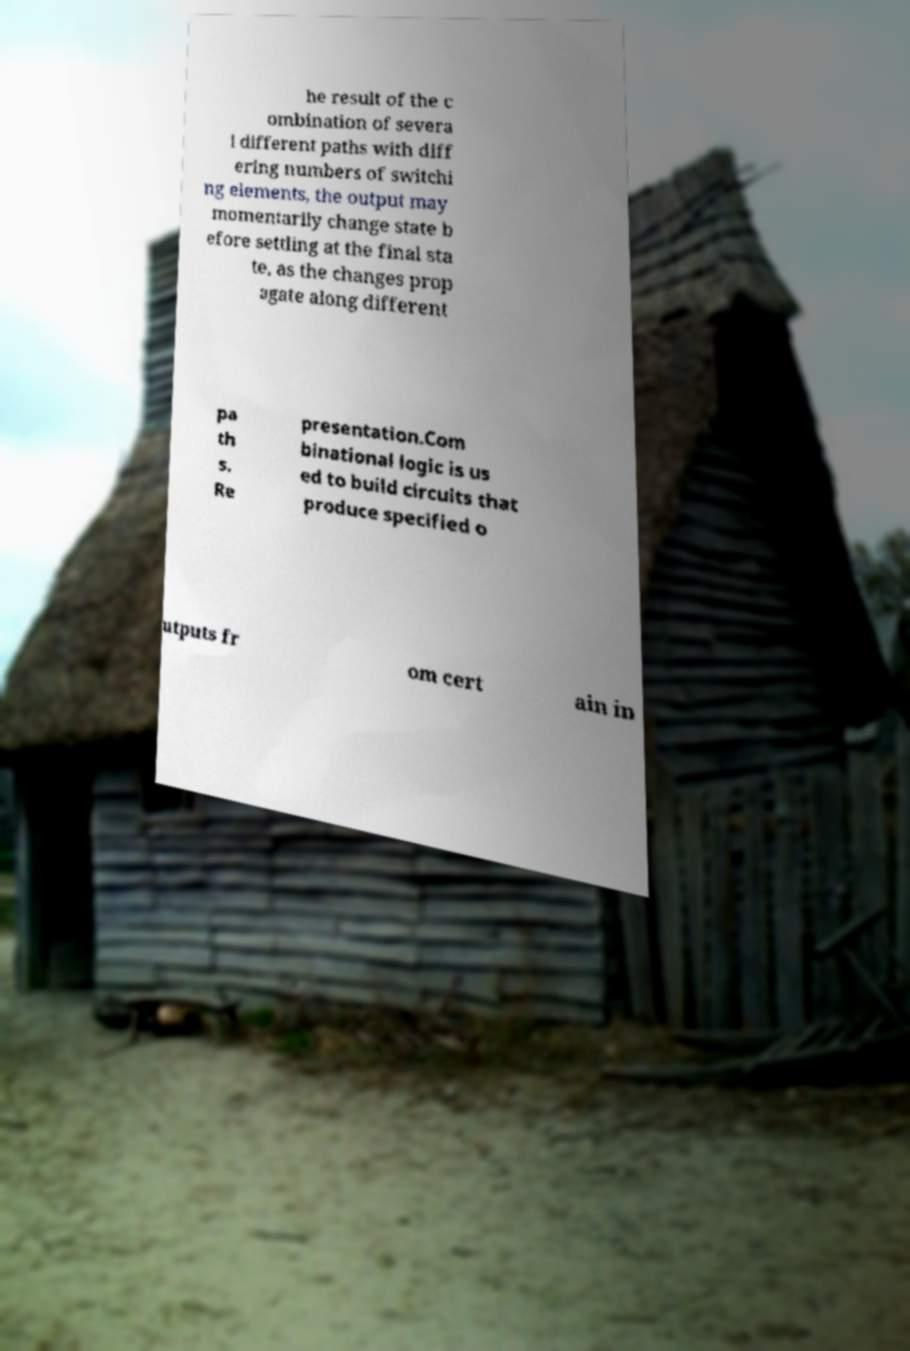Please identify and transcribe the text found in this image. he result of the c ombination of severa l different paths with diff ering numbers of switchi ng elements, the output may momentarily change state b efore settling at the final sta te, as the changes prop agate along different pa th s. Re presentation.Com binational logic is us ed to build circuits that produce specified o utputs fr om cert ain in 